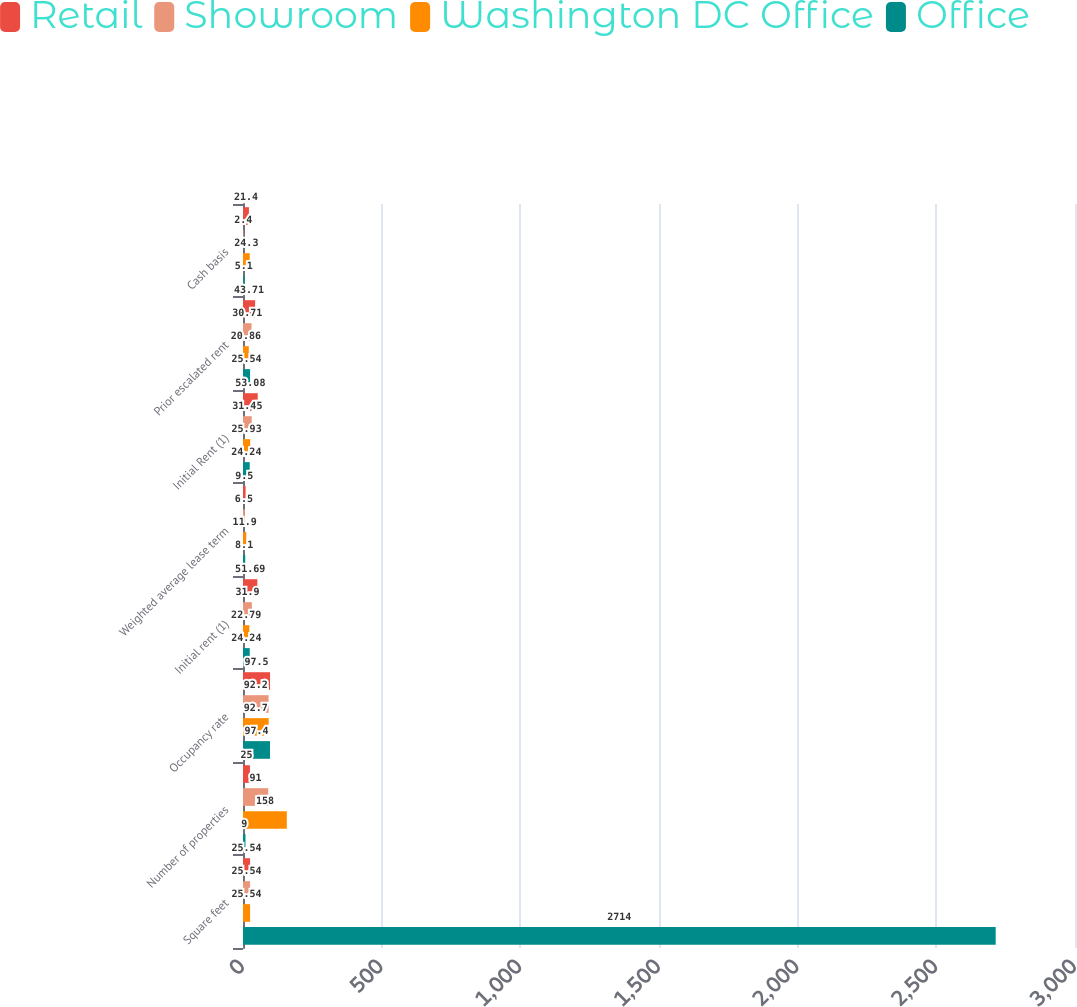Convert chart to OTSL. <chart><loc_0><loc_0><loc_500><loc_500><stacked_bar_chart><ecel><fcel>Square feet<fcel>Number of properties<fcel>Occupancy rate<fcel>Initial rent (1)<fcel>Weighted average lease term<fcel>Initial Rent (1)<fcel>Prior escalated rent<fcel>Cash basis<nl><fcel>Retail<fcel>25.54<fcel>25<fcel>97.5<fcel>51.69<fcel>9.5<fcel>53.08<fcel>43.71<fcel>21.4<nl><fcel>Showroom<fcel>25.54<fcel>91<fcel>92.2<fcel>31.9<fcel>6.5<fcel>31.45<fcel>30.71<fcel>2.4<nl><fcel>Washington DC Office<fcel>25.54<fcel>158<fcel>92.7<fcel>22.79<fcel>11.9<fcel>25.93<fcel>20.86<fcel>24.3<nl><fcel>Office<fcel>2714<fcel>9<fcel>97.4<fcel>24.24<fcel>8.1<fcel>24.24<fcel>25.54<fcel>5.1<nl></chart> 